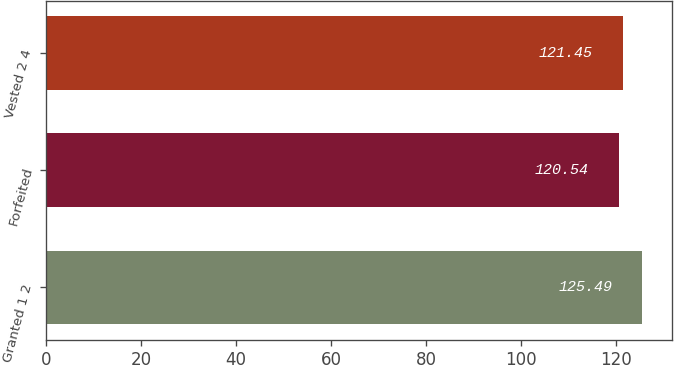<chart> <loc_0><loc_0><loc_500><loc_500><bar_chart><fcel>Granted 1 2<fcel>Forfeited<fcel>Vested 2 4<nl><fcel>125.49<fcel>120.54<fcel>121.45<nl></chart> 